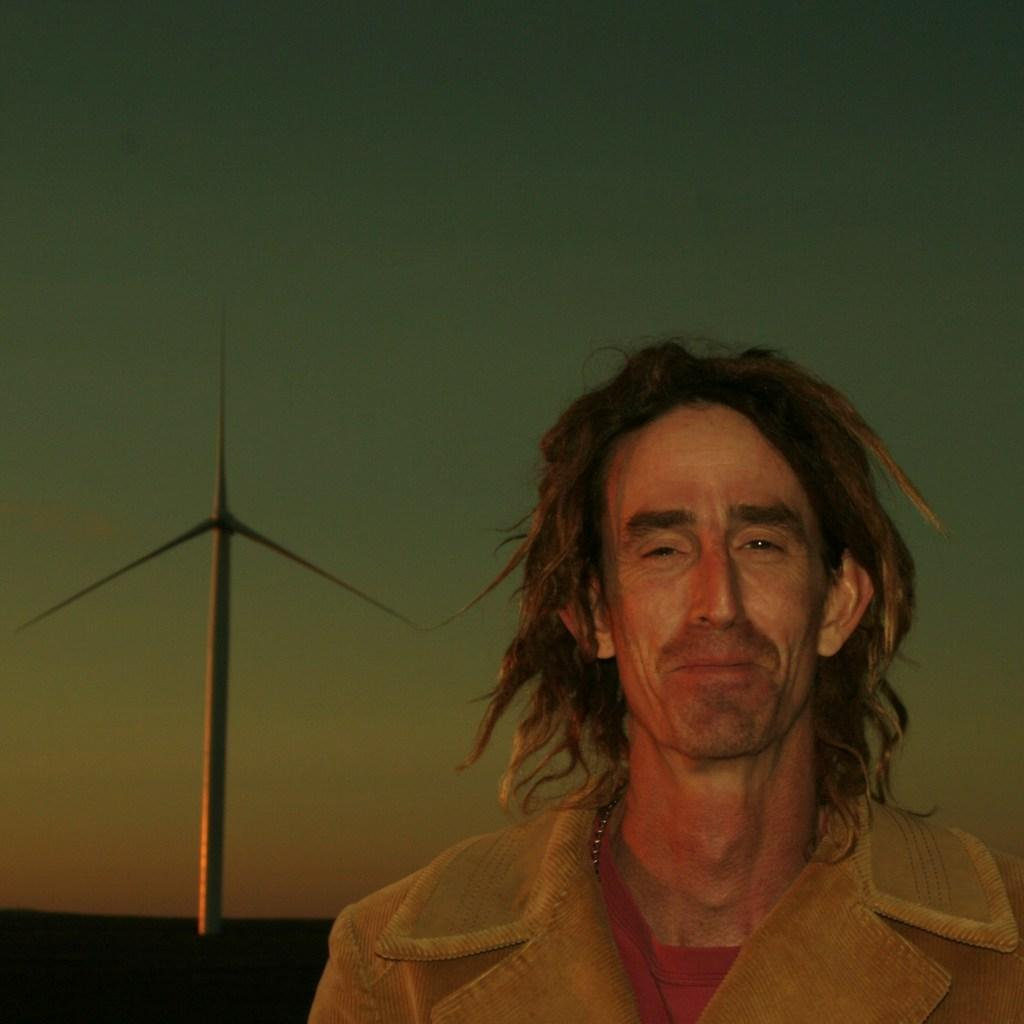What is the main subject in the foreground of the picture? There is a person in a brown jacket in the foreground of the picture. What structure can be seen on the left side of the picture? There is a windmill on the left side of the picture. What is visible in the background of the picture? The sky is visible in the background of the picture. What type of grass is growing near the windmill in the image? There is no grass visible in the image; the focus is on the person in the brown jacket and the windmill. 